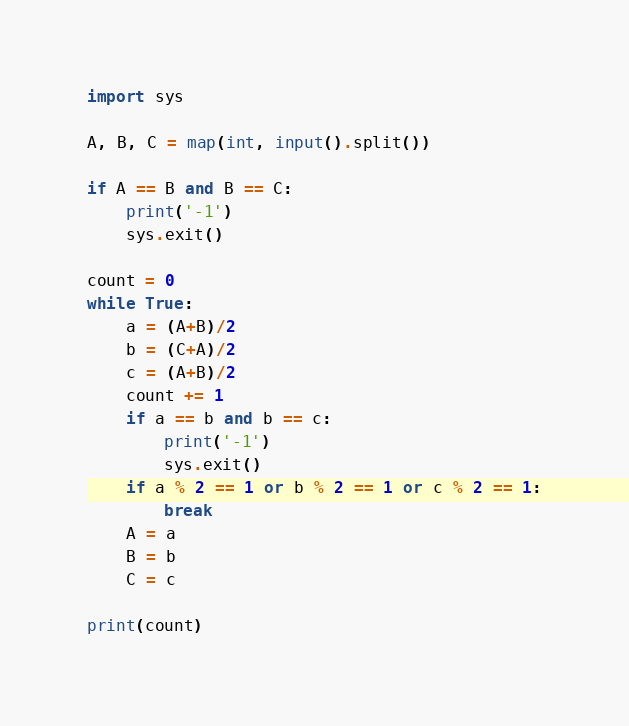<code> <loc_0><loc_0><loc_500><loc_500><_Python_>import sys

A, B, C = map(int, input().split())

if A == B and B == C:
    print('-1')
    sys.exit()

count = 0
while True:
    a = (A+B)/2
    b = (C+A)/2
    c = (A+B)/2
    count += 1
    if a == b and b == c:
        print('-1')
        sys.exit()
    if a % 2 == 1 or b % 2 == 1 or c % 2 == 1:
        break
    A = a
    B = b
    C = c

print(count)</code> 